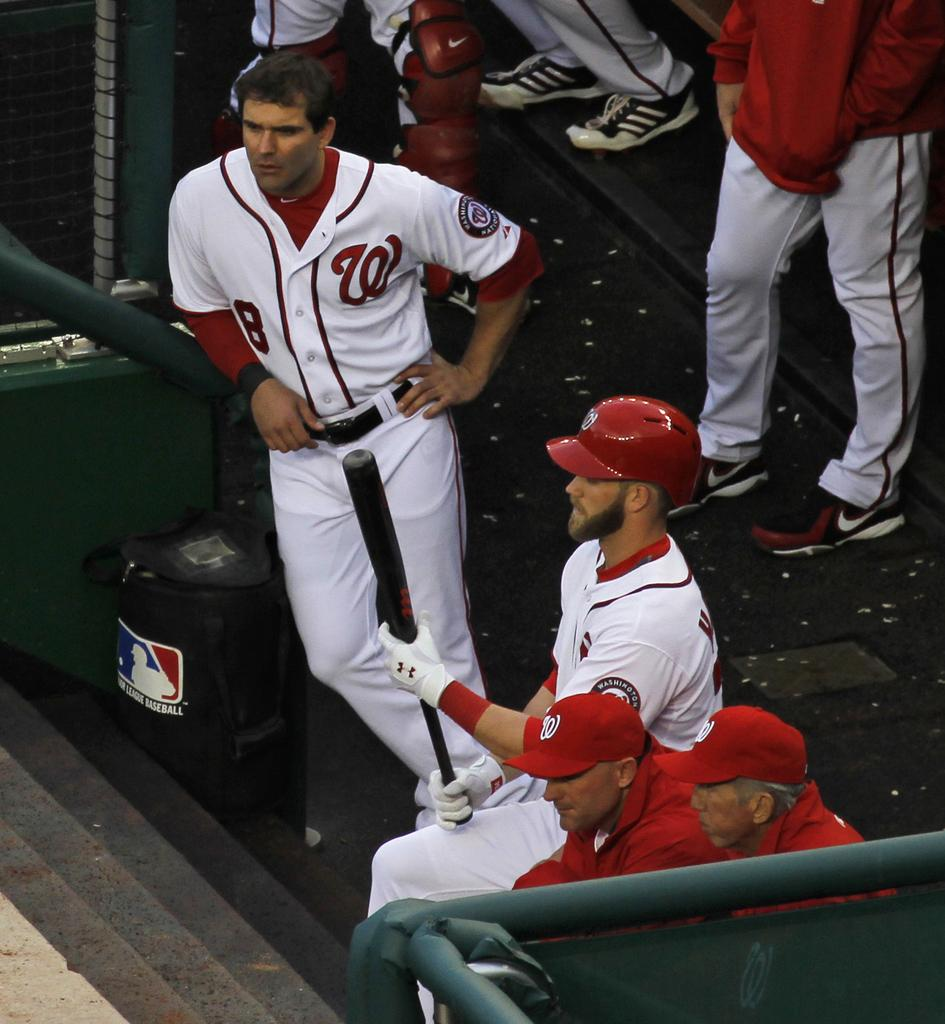Provide a one-sentence caption for the provided image. Baseball team wearing red and white uniforms with a W on the right. 